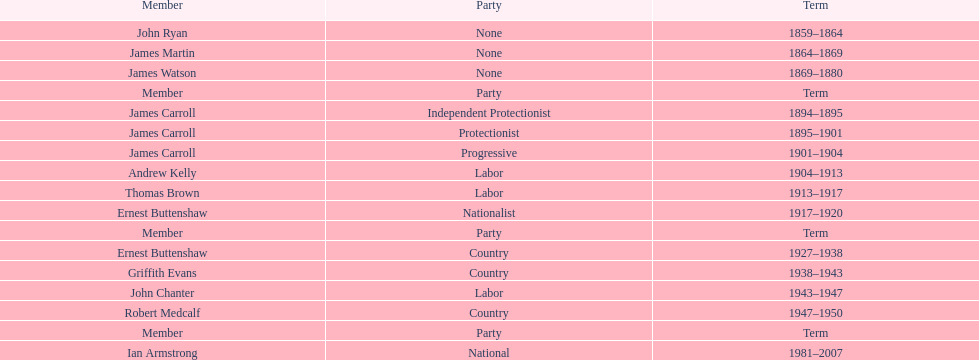What was the length of ian armstrong's tenure? 26 years. 